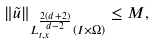<formula> <loc_0><loc_0><loc_500><loc_500>\| \tilde { u } \| _ { L _ { t , x } ^ { \frac { 2 ( d + 2 ) } { d - 2 } } ( I \times \Omega ) } \leq M ,</formula> 